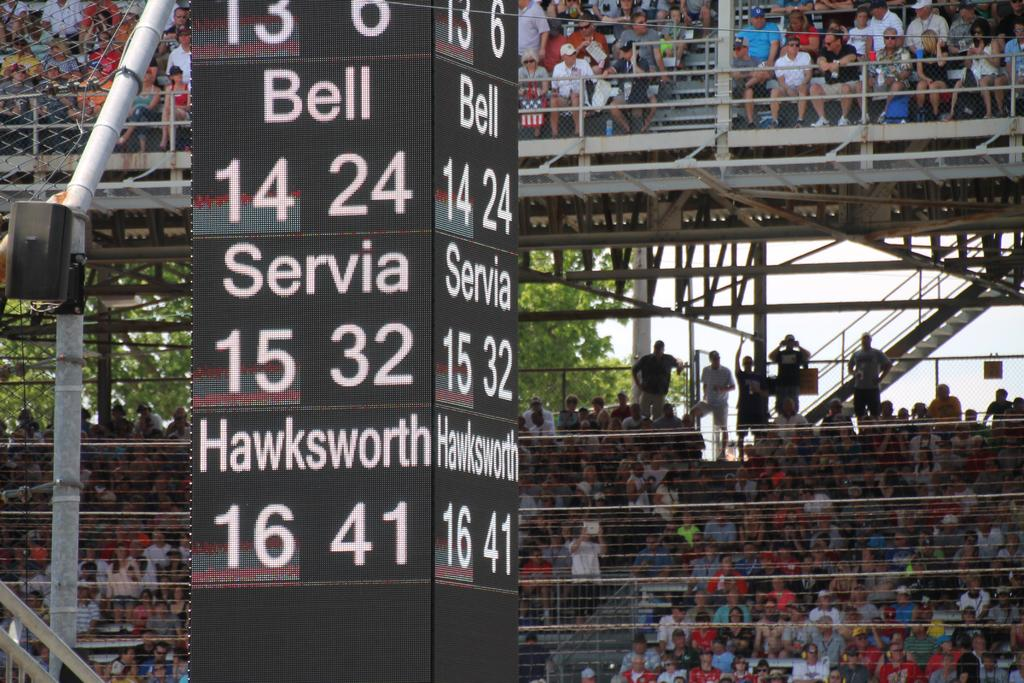<image>
Present a compact description of the photo's key features. A vertical sign says "bell, servia and hawksqorth." 